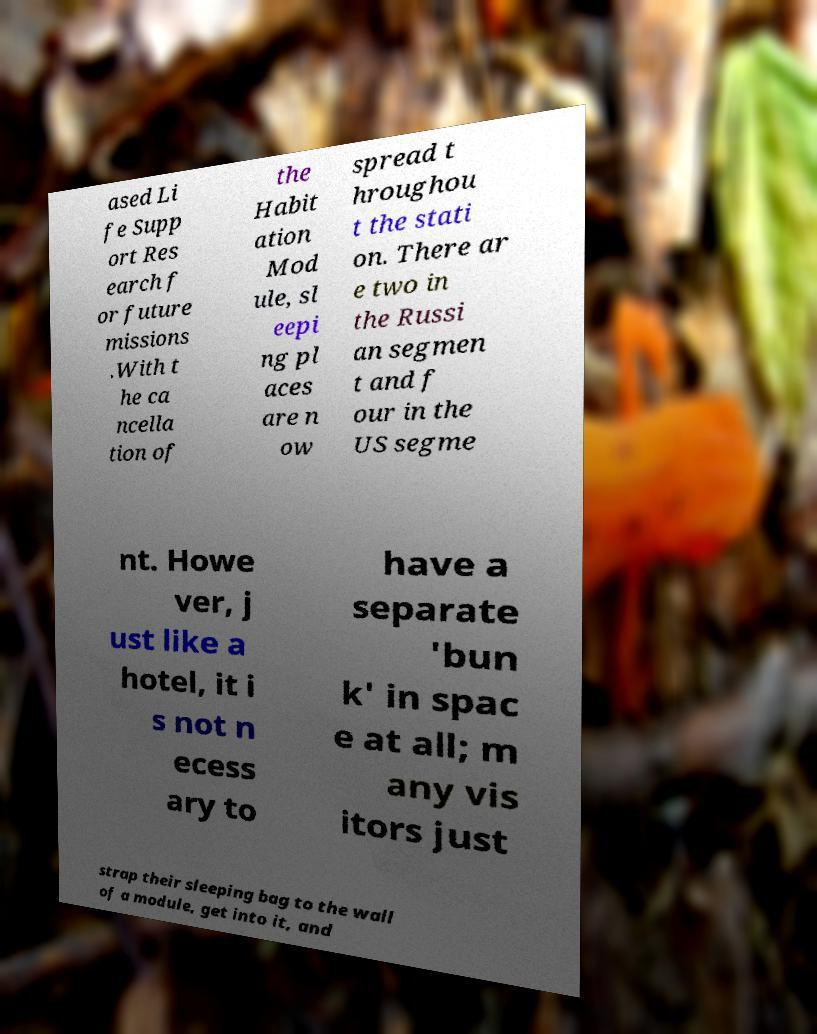Please identify and transcribe the text found in this image. ased Li fe Supp ort Res earch f or future missions .With t he ca ncella tion of the Habit ation Mod ule, sl eepi ng pl aces are n ow spread t hroughou t the stati on. There ar e two in the Russi an segmen t and f our in the US segme nt. Howe ver, j ust like a hotel, it i s not n ecess ary to have a separate 'bun k' in spac e at all; m any vis itors just strap their sleeping bag to the wall of a module, get into it, and 